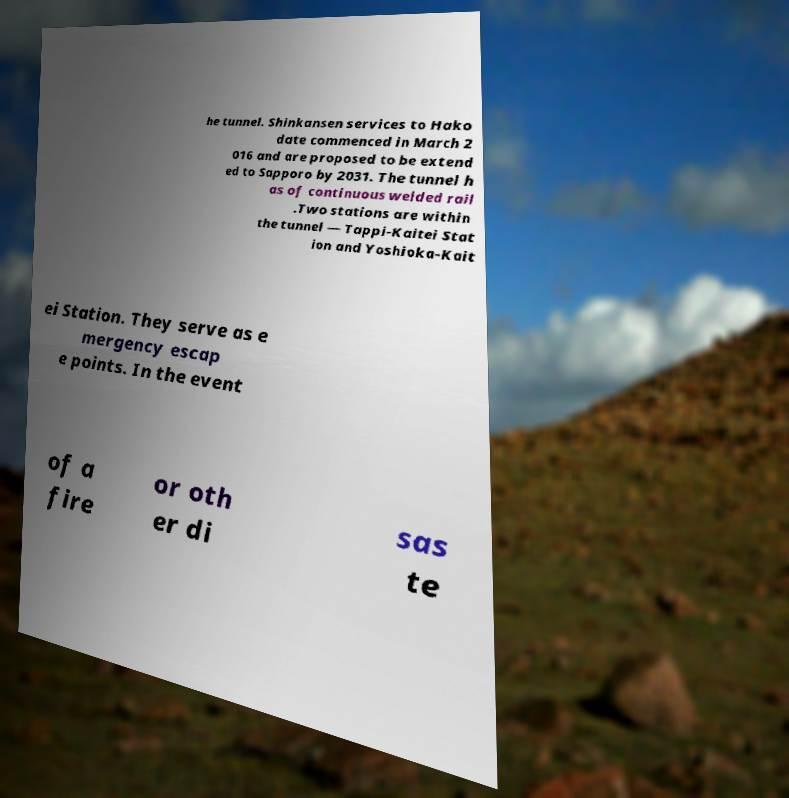Could you assist in decoding the text presented in this image and type it out clearly? he tunnel. Shinkansen services to Hako date commenced in March 2 016 and are proposed to be extend ed to Sapporo by 2031. The tunnel h as of continuous welded rail .Two stations are within the tunnel — Tappi-Kaitei Stat ion and Yoshioka-Kait ei Station. They serve as e mergency escap e points. In the event of a fire or oth er di sas te 